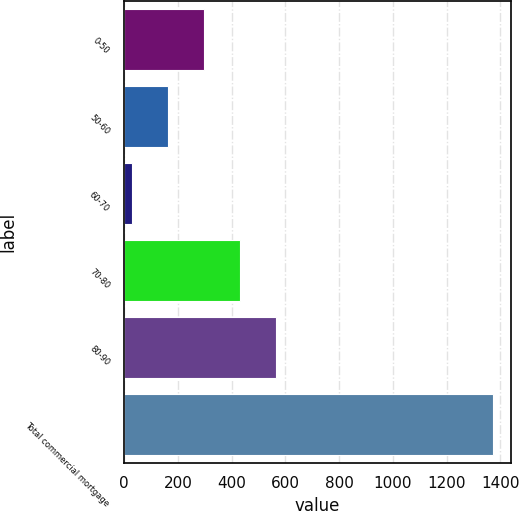<chart> <loc_0><loc_0><loc_500><loc_500><bar_chart><fcel>0-50<fcel>50-60<fcel>60-70<fcel>70-80<fcel>80-90<fcel>Total commercial mortgage<nl><fcel>296.6<fcel>162.3<fcel>28<fcel>430.9<fcel>565.2<fcel>1371<nl></chart> 